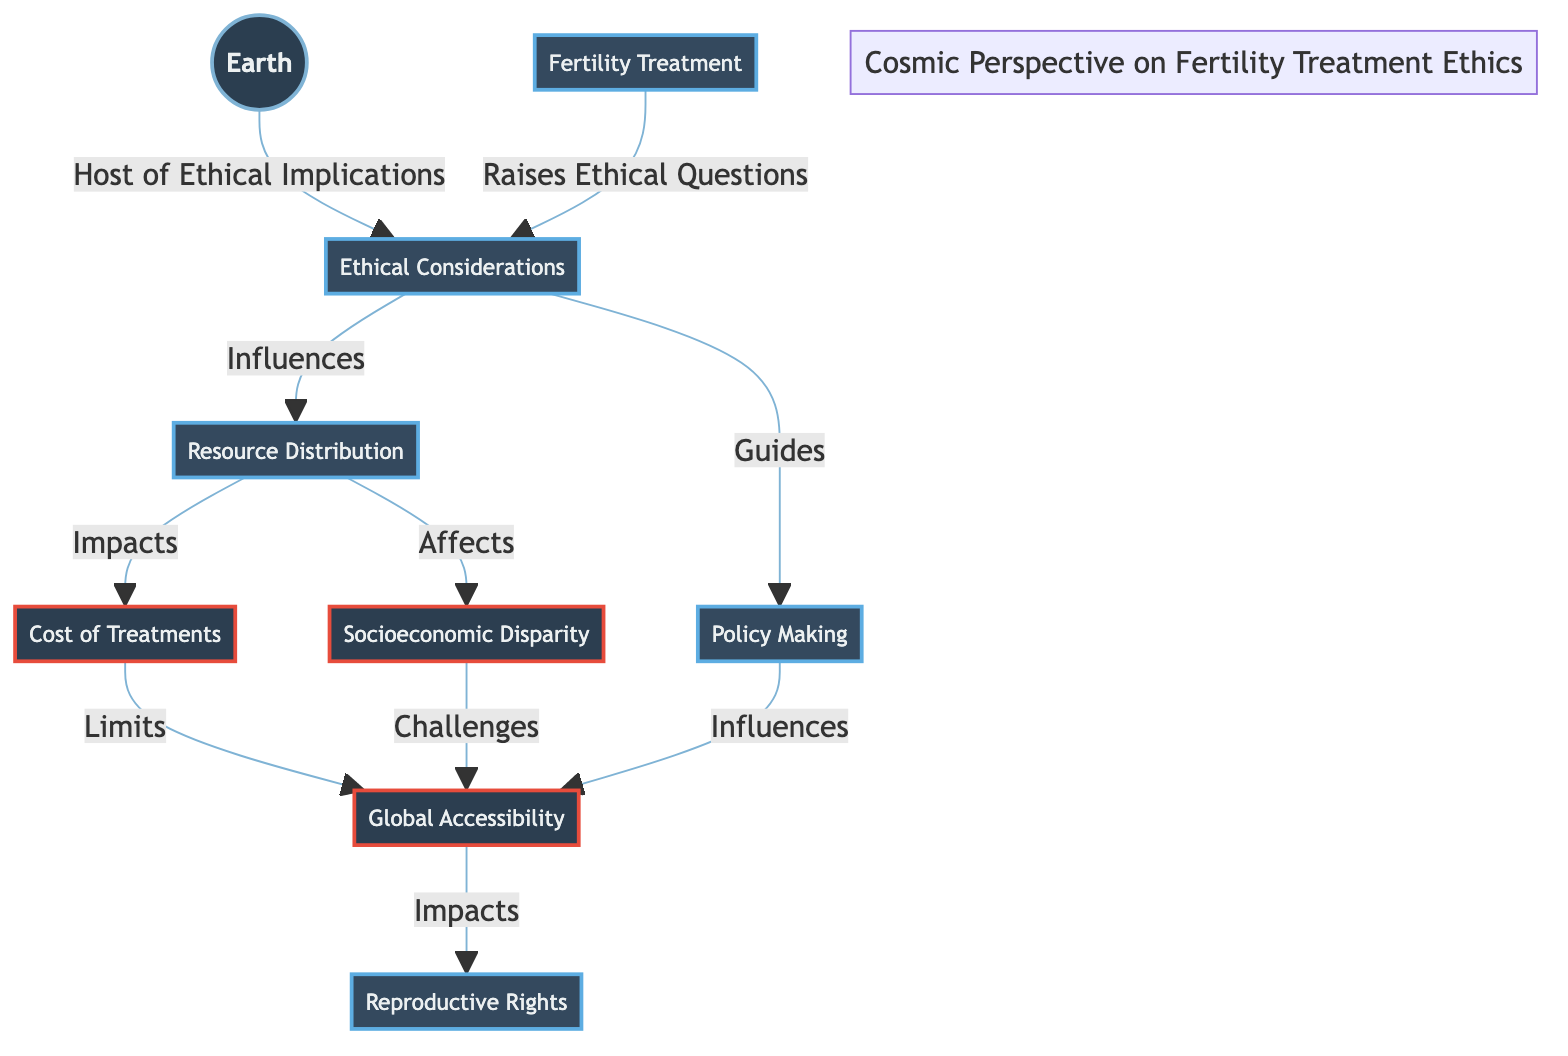What is the main topic of the diagram? The central theme of the diagram is indicated by the primary node labeled “Ethical Considerations.” This node connects multiple aspects related to fertility treatment, making it clear that ethical implications are the core subject.
Answer: Ethical Considerations How many issues are listed in the diagram? The diagram has three identified issues: "Cost of Treatments," "Socioeconomic Disparity," and "Global Accessibility." By counting these nodes, we find there are three specific issues mentioned.
Answer: 3 Which concept is influenced by "Resource Distribution"? The diagram shows a direct influence from "Resource Distribution" to "Cost of Treatments" and "Socioeconomic Disparity." Since both are outcomes of resource distribution, it indicates that resource distribution impacts both concepts.
Answer: Cost of Treatments, Socioeconomic Disparity What node does “Policy Making” influence? According to the diagram, “Policy Making” directly affects “Global Accessibility.” By following the arrow from policy making to global accessibility, one can easily see the influence.
Answer: Global Accessibility What connections does "Fertility Treatment" make in the diagram? The diagram indicates that "Fertility Treatment" connects to "Ethical Considerations," which shows that it raises ethical questions. The relation can be traced directly with an arrow from fertility treatment to ethical considerations.
Answer: Ethical Considerations How does "Socioeconomic Disparity" challenge accessibility? The diagram illustrates that "Socioeconomic Disparity" impacts "Global Accessibility" negatively. This connection implies that disparities in socioeconomic status create challenges for people trying to access fertility treatments.
Answer: Challenges Global Accessibility Which node is the final impact of "Cost of Treatments"? There is a flow from "Cost of Treatments" that leads to "Global Accessibility." The diagram clearly shows that high costs create limits, which eventually affect the ability for individuals to access treatments globally.
Answer: Global Accessibility What guides "Policy Making" according to the diagram? The diagram specifies that "Ethical Considerations" influence "Policy Making." This relationship indicates that ethical implications are used to guide decisions made within policy frameworks.
Answer: Ethical Considerations What indicates the relationship between "Resource Distribution" and "Reproductive Rights"? Following the connections in the diagram shows that "Resource Distribution" impacts "Global Accessibility," which then influences "Reproductive Rights." This means that available resources affect people's rights to reproduction overall.
Answer: Impacts Reproductive Rights 